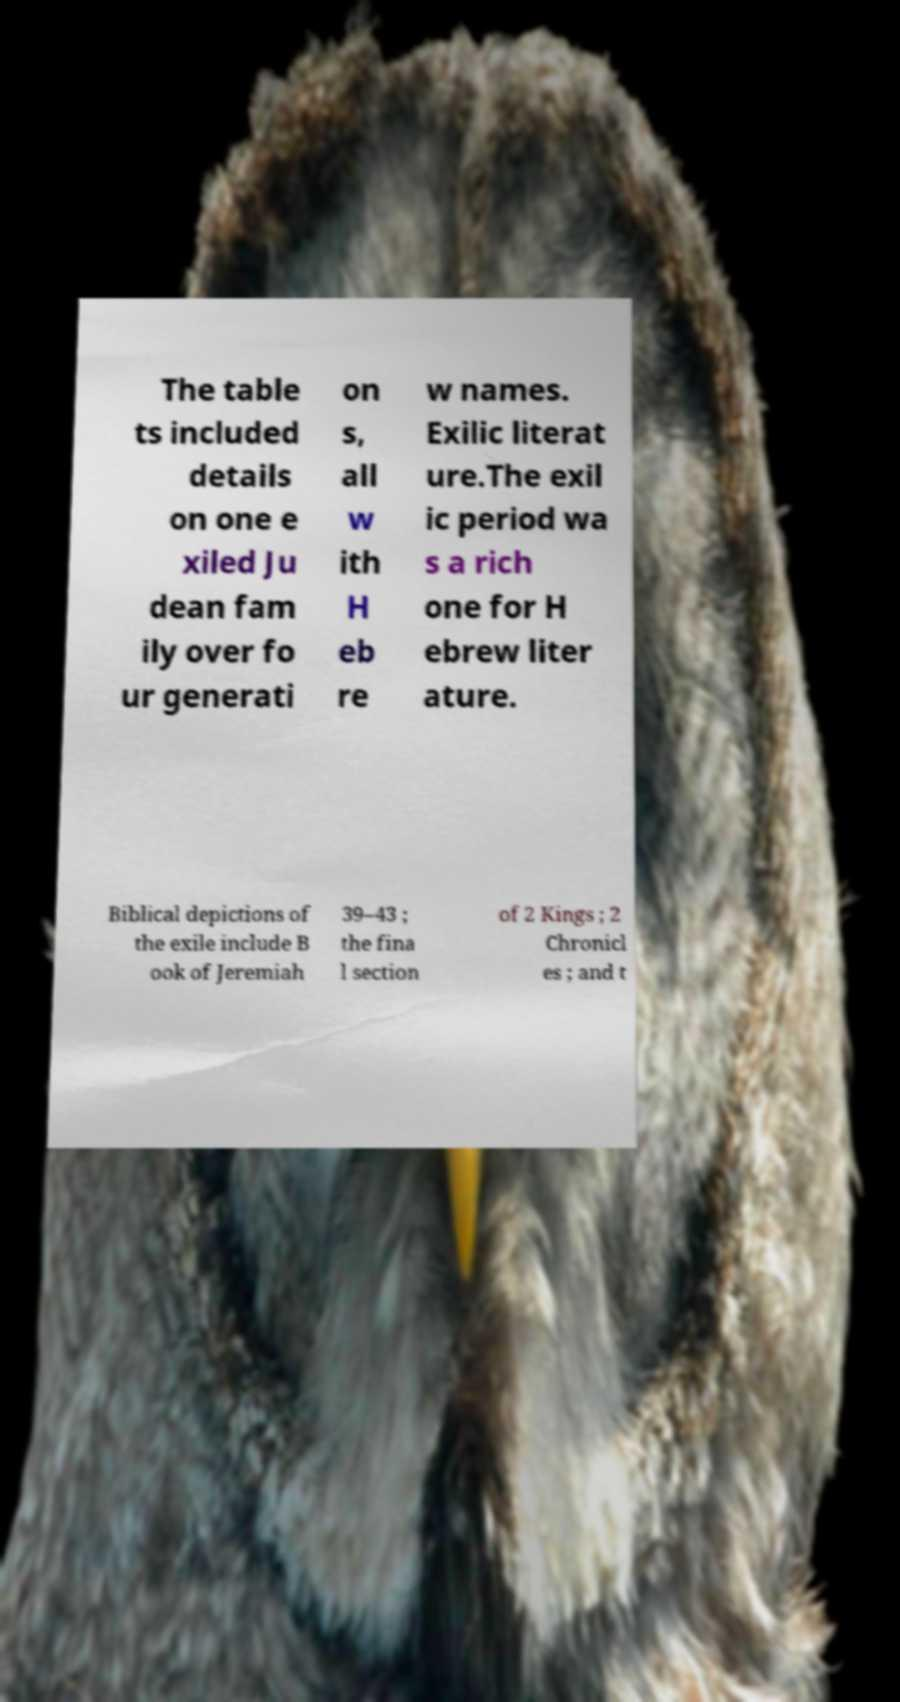Can you read and provide the text displayed in the image?This photo seems to have some interesting text. Can you extract and type it out for me? The table ts included details on one e xiled Ju dean fam ily over fo ur generati on s, all w ith H eb re w names. Exilic literat ure.The exil ic period wa s a rich one for H ebrew liter ature. Biblical depictions of the exile include B ook of Jeremiah 39–43 ; the fina l section of 2 Kings ; 2 Chronicl es ; and t 